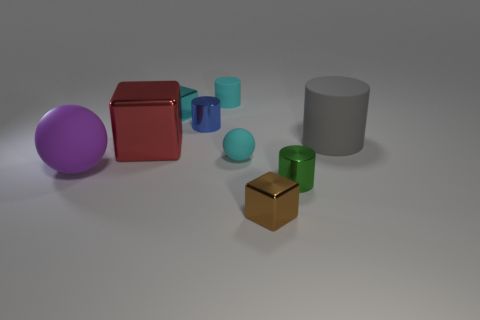Is the blue cylinder made of the same material as the big red cube?
Ensure brevity in your answer.  Yes. How many things are there?
Provide a short and direct response. 9. The small metal cylinder that is right of the metal block that is in front of the metallic cylinder that is to the right of the tiny brown metallic object is what color?
Provide a short and direct response. Green. Is the tiny rubber cylinder the same color as the big matte cylinder?
Make the answer very short. No. How many things are both in front of the small green metal object and to the left of the tiny blue cylinder?
Keep it short and to the point. 0. How many rubber objects are either green cylinders or large brown balls?
Offer a very short reply. 0. There is a block that is in front of the purple rubber thing that is in front of the cyan cube; what is its material?
Ensure brevity in your answer.  Metal. There is a small metal thing that is the same color as the tiny rubber cylinder; what shape is it?
Make the answer very short. Cube. What shape is the cyan shiny thing that is the same size as the blue thing?
Ensure brevity in your answer.  Cube. Is the number of small cyan blocks less than the number of purple shiny balls?
Ensure brevity in your answer.  No. 